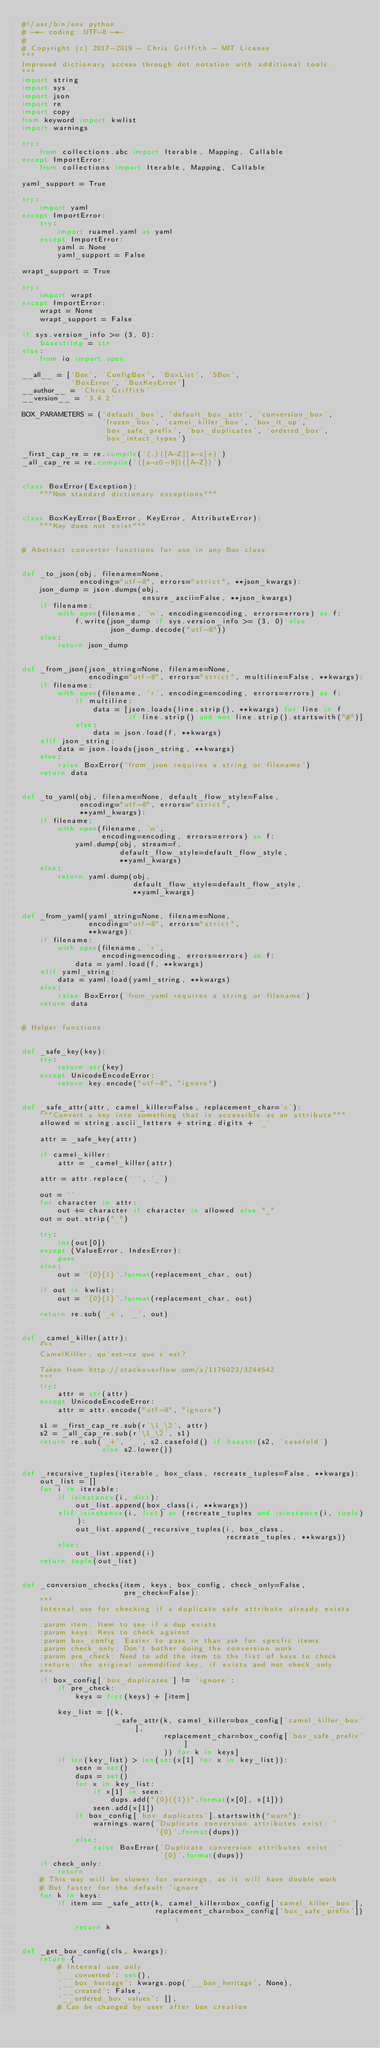Convert code to text. <code><loc_0><loc_0><loc_500><loc_500><_Python_>#!/usr/bin/env python
# -*- coding: UTF-8 -*-
#
# Copyright (c) 2017-2019 - Chris Griffith - MIT License
"""
Improved dictionary access through dot notation with additional tools.
"""
import string
import sys
import json
import re
import copy
from keyword import kwlist
import warnings

try:
    from collections.abc import Iterable, Mapping, Callable
except ImportError:
    from collections import Iterable, Mapping, Callable

yaml_support = True

try:
    import yaml
except ImportError:
    try:
        import ruamel.yaml as yaml
    except ImportError:
        yaml = None
        yaml_support = False

wrapt_support = True

try:
    import wrapt
except ImportError:
    wrapt = None
    wrapt_support = False

if sys.version_info >= (3, 0):
    basestring = str
else:
    from io import open

__all__ = ['Box', 'ConfigBox', 'BoxList', 'SBox',
           'BoxError', 'BoxKeyError']
__author__ = 'Chris Griffith'
__version__ = '3.4.2'

BOX_PARAMETERS = ('default_box', 'default_box_attr', 'conversion_box',
                  'frozen_box', 'camel_killer_box', 'box_it_up',
                  'box_safe_prefix', 'box_duplicates', 'ordered_box',
                  'box_intact_types')

_first_cap_re = re.compile('(.)([A-Z][a-z]+)')
_all_cap_re = re.compile('([a-z0-9])([A-Z])')


class BoxError(Exception):
    """Non standard dictionary exceptions"""


class BoxKeyError(BoxError, KeyError, AttributeError):
    """Key does not exist"""


# Abstract converter functions for use in any Box class


def _to_json(obj, filename=None,
             encoding="utf-8", errors="strict", **json_kwargs):
    json_dump = json.dumps(obj,
                           ensure_ascii=False, **json_kwargs)
    if filename:
        with open(filename, 'w', encoding=encoding, errors=errors) as f:
            f.write(json_dump if sys.version_info >= (3, 0) else
                    json_dump.decode("utf-8"))
    else:
        return json_dump


def _from_json(json_string=None, filename=None,
               encoding="utf-8", errors="strict", multiline=False, **kwargs):
    if filename:
        with open(filename, 'r', encoding=encoding, errors=errors) as f:
            if multiline:
                data = [json.loads(line.strip(), **kwargs) for line in f
                        if line.strip() and not line.strip().startswith("#")]
            else:
                data = json.load(f, **kwargs)
    elif json_string:
        data = json.loads(json_string, **kwargs)
    else:
        raise BoxError('from_json requires a string or filename')
    return data


def _to_yaml(obj, filename=None, default_flow_style=False,
             encoding="utf-8", errors="strict",
             **yaml_kwargs):
    if filename:
        with open(filename, 'w',
                  encoding=encoding, errors=errors) as f:
            yaml.dump(obj, stream=f,
                      default_flow_style=default_flow_style,
                      **yaml_kwargs)
    else:
        return yaml.dump(obj,
                         default_flow_style=default_flow_style,
                         **yaml_kwargs)


def _from_yaml(yaml_string=None, filename=None,
               encoding="utf-8", errors="strict",
               **kwargs):
    if filename:
        with open(filename, 'r',
                  encoding=encoding, errors=errors) as f:
            data = yaml.load(f, **kwargs)
    elif yaml_string:
        data = yaml.load(yaml_string, **kwargs)
    else:
        raise BoxError('from_yaml requires a string or filename')
    return data


# Helper functions


def _safe_key(key):
    try:
        return str(key)
    except UnicodeEncodeError:
        return key.encode("utf-8", "ignore")


def _safe_attr(attr, camel_killer=False, replacement_char='x'):
    """Convert a key into something that is accessible as an attribute"""
    allowed = string.ascii_letters + string.digits + '_'

    attr = _safe_key(attr)

    if camel_killer:
        attr = _camel_killer(attr)

    attr = attr.replace(' ', '_')

    out = ''
    for character in attr:
        out += character if character in allowed else "_"
    out = out.strip("_")

    try:
        int(out[0])
    except (ValueError, IndexError):
        pass
    else:
        out = '{0}{1}'.format(replacement_char, out)

    if out in kwlist:
        out = '{0}{1}'.format(replacement_char, out)

    return re.sub('_+', '_', out)


def _camel_killer(attr):
    """
    CamelKiller, qu'est-ce que c'est?

    Taken from http://stackoverflow.com/a/1176023/3244542
    """
    try:
        attr = str(attr)
    except UnicodeEncodeError:
        attr = attr.encode("utf-8", "ignore")

    s1 = _first_cap_re.sub(r'\1_\2', attr)
    s2 = _all_cap_re.sub(r'\1_\2', s1)
    return re.sub('_+', '_', s2.casefold() if hasattr(s2, 'casefold')
                  else s2.lower())


def _recursive_tuples(iterable, box_class, recreate_tuples=False, **kwargs):
    out_list = []
    for i in iterable:
        if isinstance(i, dict):
            out_list.append(box_class(i, **kwargs))
        elif isinstance(i, list) or (recreate_tuples and isinstance(i, tuple)):
            out_list.append(_recursive_tuples(i, box_class,
                                              recreate_tuples, **kwargs))
        else:
            out_list.append(i)
    return tuple(out_list)


def _conversion_checks(item, keys, box_config, check_only=False,
                       pre_check=False):
    """
    Internal use for checking if a duplicate safe attribute already exists

    :param item: Item to see if a dup exists
    :param keys: Keys to check against
    :param box_config: Easier to pass in than ask for specfic items
    :param check_only: Don't bother doing the conversion work
    :param pre_check: Need to add the item to the list of keys to check
    :return: the original unmodified key, if exists and not check_only
    """
    if box_config['box_duplicates'] != 'ignore':
        if pre_check:
            keys = list(keys) + [item]

        key_list = [(k,
                     _safe_attr(k, camel_killer=box_config['camel_killer_box'],
                                replacement_char=box_config['box_safe_prefix']
                                )) for k in keys]
        if len(key_list) > len(set(x[1] for x in key_list)):
            seen = set()
            dups = set()
            for x in key_list:
                if x[1] in seen:
                    dups.add("{0}({1})".format(x[0], x[1]))
                seen.add(x[1])
            if box_config['box_duplicates'].startswith("warn"):
                warnings.warn('Duplicate conversion attributes exist: '
                              '{0}'.format(dups))
            else:
                raise BoxError('Duplicate conversion attributes exist: '
                               '{0}'.format(dups))
    if check_only:
        return
    # This way will be slower for warnings, as it will have double work
    # But faster for the default 'ignore'
    for k in keys:
        if item == _safe_attr(k, camel_killer=box_config['camel_killer_box'],
                              replacement_char=box_config['box_safe_prefix']):
            return k


def _get_box_config(cls, kwargs):
    return {
        # Internal use only
        '__converted': set(),
        '__box_heritage': kwargs.pop('__box_heritage', None),
        '__created': False,
        '__ordered_box_values': [],
        # Can be changed by user after box creation</code> 